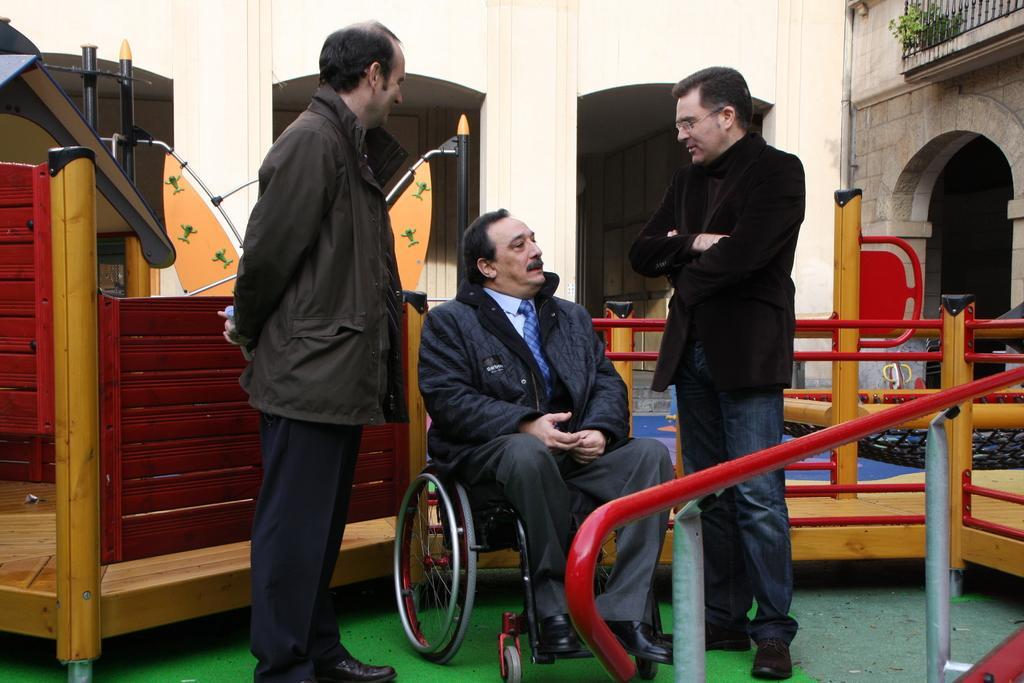Please provide a concise description of this image. This is the man sitting in the wheelchair. There are two men standing. This looks like a wooden object. Here is the wall. I think these are the pillars. This looks like a small plant. This looks like an arch. 